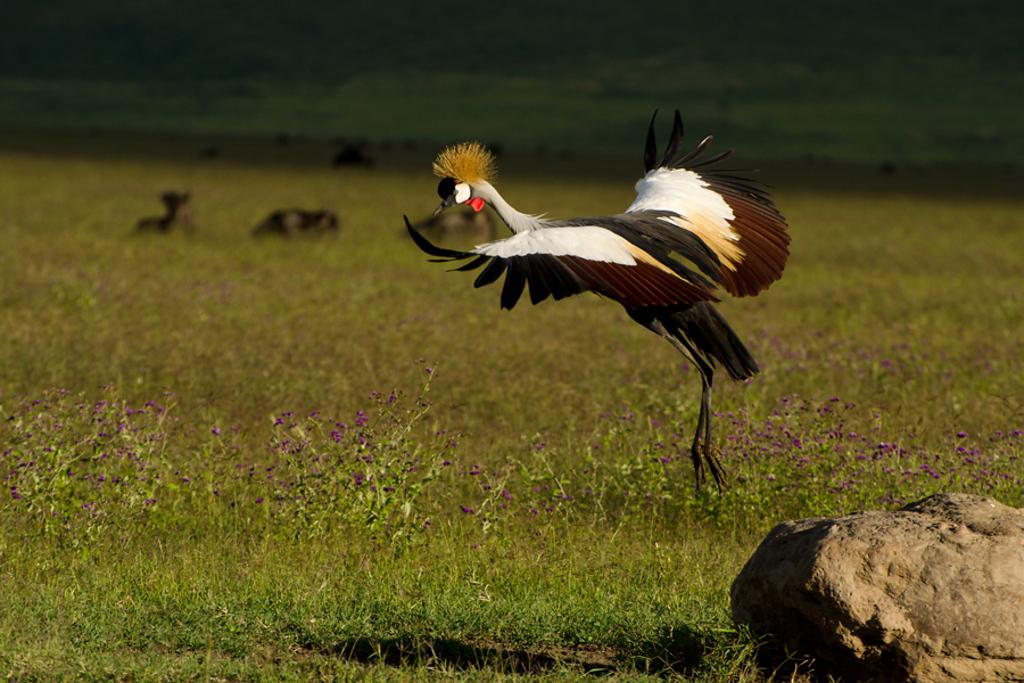What is the main object in the picture? There is a stone in the picture. What is happening in the sky in the picture? There is a bird flying in the picture. What type of plants can be seen in the picture? There are plants with flowers in the picture. What other living creatures are present in the picture? There are animals present in the picture. What type of rail can be seen in the picture? There is no rail present in the picture. How many sticks are visible in the picture? There are no sticks visible in the picture. 